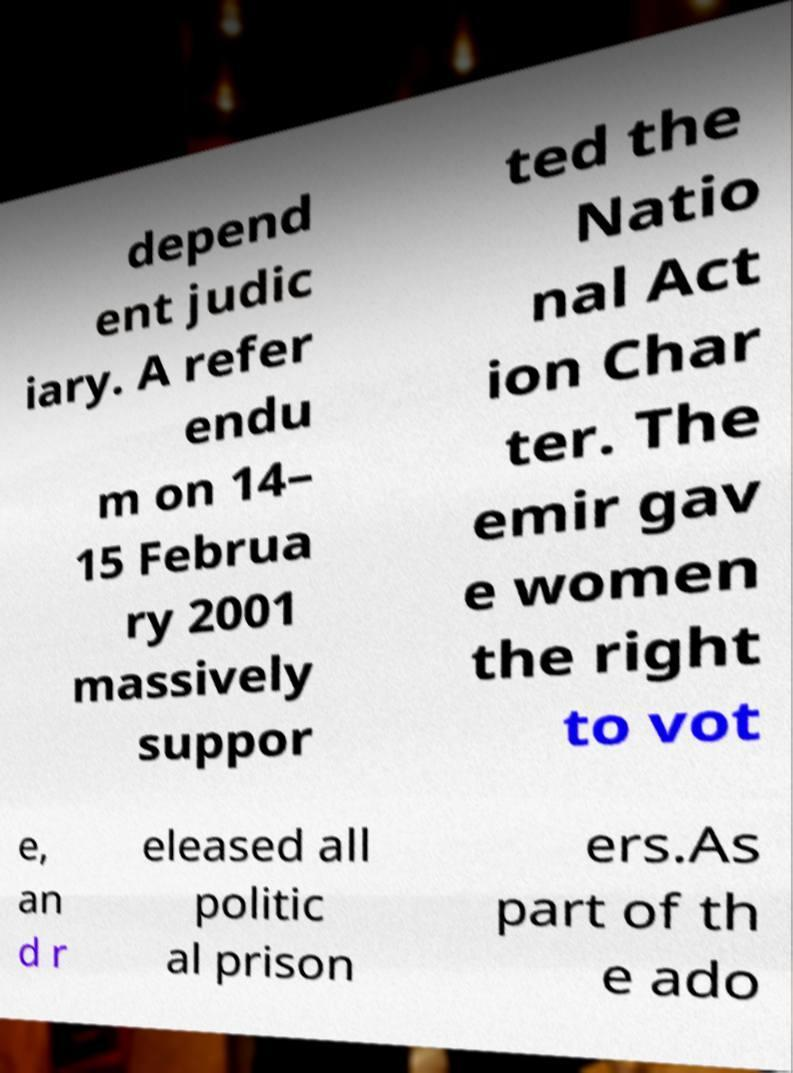Can you accurately transcribe the text from the provided image for me? depend ent judic iary. A refer endu m on 14– 15 Februa ry 2001 massively suppor ted the Natio nal Act ion Char ter. The emir gav e women the right to vot e, an d r eleased all politic al prison ers.As part of th e ado 